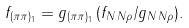Convert formula to latex. <formula><loc_0><loc_0><loc_500><loc_500>f _ { ( \pi \pi ) _ { 1 } } = g _ { ( \pi \pi ) _ { 1 } } \, ( f _ { N \, N \rho } / g _ { N \, N \rho } ) .</formula> 